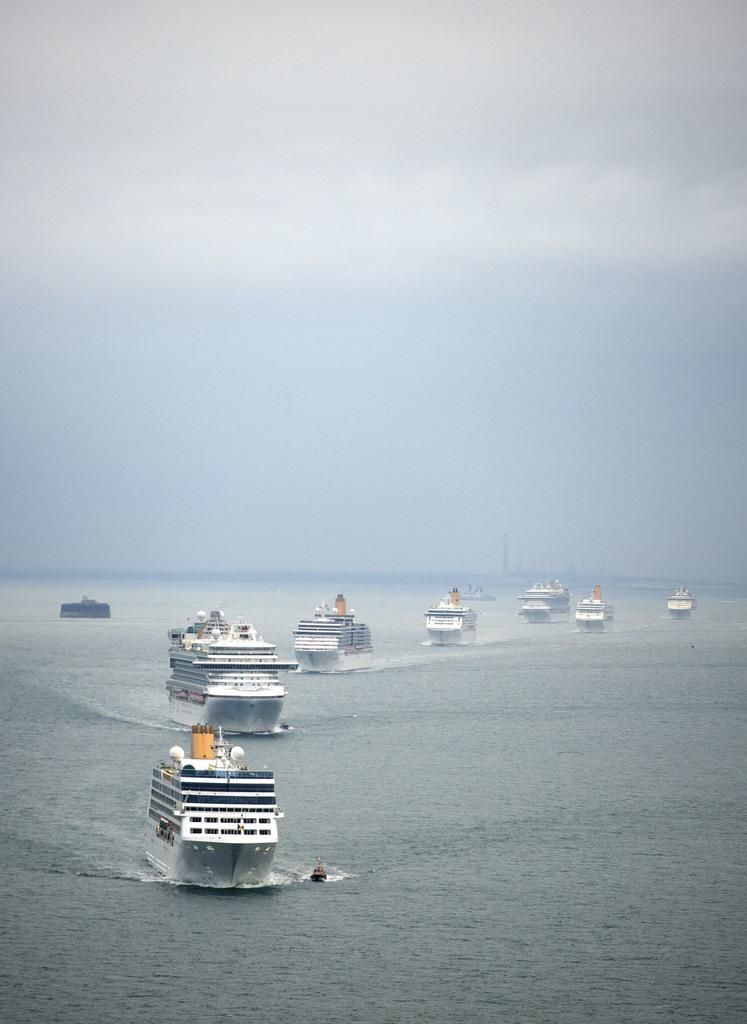What is the main subject of the image? The main subject of the image is ships. Where are the ships located in the image? The ships are on the water. What color are the ships in the image? The ships are white in color. What can be seen in the background of the image? The sky is visible in the background of the image. What color is the sky in the image? The sky is white in color. Can you tell me how many pets are on the ships in the image? There is no information about pets in the image; it only features ships on the water. 